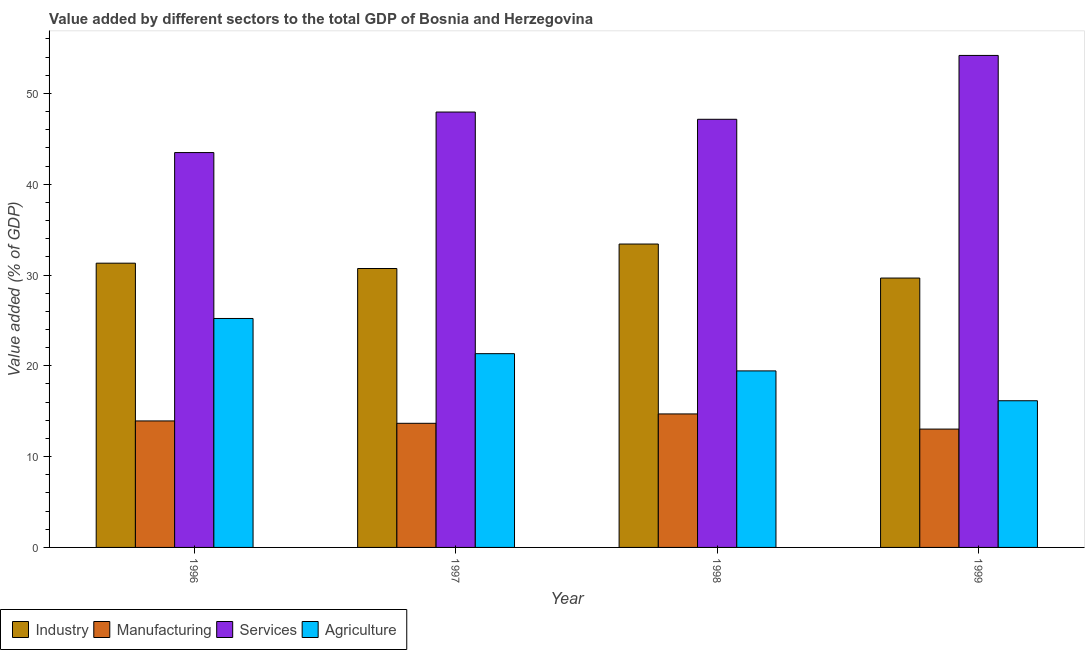How many different coloured bars are there?
Your response must be concise. 4. How many groups of bars are there?
Offer a very short reply. 4. Are the number of bars per tick equal to the number of legend labels?
Offer a terse response. Yes. How many bars are there on the 2nd tick from the left?
Your answer should be compact. 4. In how many cases, is the number of bars for a given year not equal to the number of legend labels?
Make the answer very short. 0. What is the value added by industrial sector in 1998?
Offer a very short reply. 33.41. Across all years, what is the maximum value added by services sector?
Offer a terse response. 54.18. Across all years, what is the minimum value added by manufacturing sector?
Offer a terse response. 13.03. In which year was the value added by services sector maximum?
Offer a terse response. 1999. What is the total value added by industrial sector in the graph?
Your response must be concise. 125.09. What is the difference between the value added by agricultural sector in 1997 and that in 1998?
Offer a terse response. 1.9. What is the difference between the value added by industrial sector in 1997 and the value added by services sector in 1998?
Your answer should be compact. -2.69. What is the average value added by industrial sector per year?
Keep it short and to the point. 31.27. What is the ratio of the value added by industrial sector in 1997 to that in 1999?
Your response must be concise. 1.04. Is the difference between the value added by manufacturing sector in 1997 and 1999 greater than the difference between the value added by services sector in 1997 and 1999?
Make the answer very short. No. What is the difference between the highest and the second highest value added by agricultural sector?
Offer a terse response. 3.88. What is the difference between the highest and the lowest value added by manufacturing sector?
Your response must be concise. 1.67. In how many years, is the value added by services sector greater than the average value added by services sector taken over all years?
Offer a very short reply. 1. Is the sum of the value added by industrial sector in 1996 and 1998 greater than the maximum value added by services sector across all years?
Your answer should be compact. Yes. What does the 2nd bar from the left in 1998 represents?
Ensure brevity in your answer.  Manufacturing. What does the 1st bar from the right in 1996 represents?
Your answer should be very brief. Agriculture. How many bars are there?
Your answer should be compact. 16. How many years are there in the graph?
Provide a succinct answer. 4. Are the values on the major ticks of Y-axis written in scientific E-notation?
Your response must be concise. No. Does the graph contain grids?
Give a very brief answer. No. What is the title of the graph?
Your response must be concise. Value added by different sectors to the total GDP of Bosnia and Herzegovina. What is the label or title of the X-axis?
Keep it short and to the point. Year. What is the label or title of the Y-axis?
Make the answer very short. Value added (% of GDP). What is the Value added (% of GDP) in Industry in 1996?
Offer a very short reply. 31.3. What is the Value added (% of GDP) in Manufacturing in 1996?
Your answer should be very brief. 13.93. What is the Value added (% of GDP) in Services in 1996?
Offer a very short reply. 43.48. What is the Value added (% of GDP) of Agriculture in 1996?
Your answer should be very brief. 25.21. What is the Value added (% of GDP) of Industry in 1997?
Your response must be concise. 30.72. What is the Value added (% of GDP) in Manufacturing in 1997?
Your response must be concise. 13.67. What is the Value added (% of GDP) in Services in 1997?
Keep it short and to the point. 47.95. What is the Value added (% of GDP) of Agriculture in 1997?
Your answer should be very brief. 21.34. What is the Value added (% of GDP) of Industry in 1998?
Provide a succinct answer. 33.41. What is the Value added (% of GDP) of Manufacturing in 1998?
Your answer should be very brief. 14.7. What is the Value added (% of GDP) of Services in 1998?
Ensure brevity in your answer.  47.15. What is the Value added (% of GDP) in Agriculture in 1998?
Give a very brief answer. 19.44. What is the Value added (% of GDP) of Industry in 1999?
Ensure brevity in your answer.  29.66. What is the Value added (% of GDP) of Manufacturing in 1999?
Offer a terse response. 13.03. What is the Value added (% of GDP) in Services in 1999?
Provide a short and direct response. 54.18. What is the Value added (% of GDP) of Agriculture in 1999?
Your response must be concise. 16.15. Across all years, what is the maximum Value added (% of GDP) in Industry?
Your response must be concise. 33.41. Across all years, what is the maximum Value added (% of GDP) in Manufacturing?
Your answer should be very brief. 14.7. Across all years, what is the maximum Value added (% of GDP) of Services?
Give a very brief answer. 54.18. Across all years, what is the maximum Value added (% of GDP) in Agriculture?
Offer a terse response. 25.21. Across all years, what is the minimum Value added (% of GDP) of Industry?
Your response must be concise. 29.66. Across all years, what is the minimum Value added (% of GDP) of Manufacturing?
Provide a short and direct response. 13.03. Across all years, what is the minimum Value added (% of GDP) of Services?
Your response must be concise. 43.48. Across all years, what is the minimum Value added (% of GDP) of Agriculture?
Your response must be concise. 16.15. What is the total Value added (% of GDP) in Industry in the graph?
Keep it short and to the point. 125.09. What is the total Value added (% of GDP) in Manufacturing in the graph?
Your answer should be compact. 55.33. What is the total Value added (% of GDP) in Services in the graph?
Provide a succinct answer. 192.76. What is the total Value added (% of GDP) of Agriculture in the graph?
Give a very brief answer. 82.14. What is the difference between the Value added (% of GDP) in Industry in 1996 and that in 1997?
Provide a short and direct response. 0.59. What is the difference between the Value added (% of GDP) of Manufacturing in 1996 and that in 1997?
Give a very brief answer. 0.26. What is the difference between the Value added (% of GDP) in Services in 1996 and that in 1997?
Give a very brief answer. -4.46. What is the difference between the Value added (% of GDP) of Agriculture in 1996 and that in 1997?
Provide a short and direct response. 3.88. What is the difference between the Value added (% of GDP) in Industry in 1996 and that in 1998?
Make the answer very short. -2.11. What is the difference between the Value added (% of GDP) in Manufacturing in 1996 and that in 1998?
Make the answer very short. -0.77. What is the difference between the Value added (% of GDP) in Services in 1996 and that in 1998?
Your answer should be compact. -3.67. What is the difference between the Value added (% of GDP) in Agriculture in 1996 and that in 1998?
Offer a terse response. 5.77. What is the difference between the Value added (% of GDP) in Industry in 1996 and that in 1999?
Provide a succinct answer. 1.64. What is the difference between the Value added (% of GDP) of Manufacturing in 1996 and that in 1999?
Keep it short and to the point. 0.9. What is the difference between the Value added (% of GDP) in Services in 1996 and that in 1999?
Offer a very short reply. -10.7. What is the difference between the Value added (% of GDP) of Agriculture in 1996 and that in 1999?
Make the answer very short. 9.06. What is the difference between the Value added (% of GDP) in Industry in 1997 and that in 1998?
Provide a succinct answer. -2.69. What is the difference between the Value added (% of GDP) in Manufacturing in 1997 and that in 1998?
Give a very brief answer. -1.03. What is the difference between the Value added (% of GDP) in Services in 1997 and that in 1998?
Give a very brief answer. 0.8. What is the difference between the Value added (% of GDP) of Agriculture in 1997 and that in 1998?
Ensure brevity in your answer.  1.9. What is the difference between the Value added (% of GDP) of Industry in 1997 and that in 1999?
Offer a very short reply. 1.05. What is the difference between the Value added (% of GDP) of Manufacturing in 1997 and that in 1999?
Ensure brevity in your answer.  0.64. What is the difference between the Value added (% of GDP) in Services in 1997 and that in 1999?
Your answer should be compact. -6.24. What is the difference between the Value added (% of GDP) of Agriculture in 1997 and that in 1999?
Provide a short and direct response. 5.18. What is the difference between the Value added (% of GDP) of Industry in 1998 and that in 1999?
Your answer should be compact. 3.75. What is the difference between the Value added (% of GDP) of Manufacturing in 1998 and that in 1999?
Ensure brevity in your answer.  1.67. What is the difference between the Value added (% of GDP) in Services in 1998 and that in 1999?
Offer a very short reply. -7.03. What is the difference between the Value added (% of GDP) in Agriculture in 1998 and that in 1999?
Your answer should be very brief. 3.29. What is the difference between the Value added (% of GDP) of Industry in 1996 and the Value added (% of GDP) of Manufacturing in 1997?
Offer a terse response. 17.63. What is the difference between the Value added (% of GDP) in Industry in 1996 and the Value added (% of GDP) in Services in 1997?
Offer a very short reply. -16.64. What is the difference between the Value added (% of GDP) in Industry in 1996 and the Value added (% of GDP) in Agriculture in 1997?
Give a very brief answer. 9.97. What is the difference between the Value added (% of GDP) in Manufacturing in 1996 and the Value added (% of GDP) in Services in 1997?
Offer a terse response. -34.02. What is the difference between the Value added (% of GDP) in Manufacturing in 1996 and the Value added (% of GDP) in Agriculture in 1997?
Your response must be concise. -7.41. What is the difference between the Value added (% of GDP) in Services in 1996 and the Value added (% of GDP) in Agriculture in 1997?
Ensure brevity in your answer.  22.15. What is the difference between the Value added (% of GDP) in Industry in 1996 and the Value added (% of GDP) in Manufacturing in 1998?
Your answer should be very brief. 16.6. What is the difference between the Value added (% of GDP) of Industry in 1996 and the Value added (% of GDP) of Services in 1998?
Your answer should be compact. -15.85. What is the difference between the Value added (% of GDP) of Industry in 1996 and the Value added (% of GDP) of Agriculture in 1998?
Offer a terse response. 11.86. What is the difference between the Value added (% of GDP) of Manufacturing in 1996 and the Value added (% of GDP) of Services in 1998?
Give a very brief answer. -33.22. What is the difference between the Value added (% of GDP) of Manufacturing in 1996 and the Value added (% of GDP) of Agriculture in 1998?
Provide a succinct answer. -5.51. What is the difference between the Value added (% of GDP) in Services in 1996 and the Value added (% of GDP) in Agriculture in 1998?
Provide a short and direct response. 24.04. What is the difference between the Value added (% of GDP) of Industry in 1996 and the Value added (% of GDP) of Manufacturing in 1999?
Keep it short and to the point. 18.27. What is the difference between the Value added (% of GDP) of Industry in 1996 and the Value added (% of GDP) of Services in 1999?
Ensure brevity in your answer.  -22.88. What is the difference between the Value added (% of GDP) of Industry in 1996 and the Value added (% of GDP) of Agriculture in 1999?
Offer a very short reply. 15.15. What is the difference between the Value added (% of GDP) in Manufacturing in 1996 and the Value added (% of GDP) in Services in 1999?
Provide a short and direct response. -40.25. What is the difference between the Value added (% of GDP) of Manufacturing in 1996 and the Value added (% of GDP) of Agriculture in 1999?
Offer a very short reply. -2.22. What is the difference between the Value added (% of GDP) in Services in 1996 and the Value added (% of GDP) in Agriculture in 1999?
Offer a very short reply. 27.33. What is the difference between the Value added (% of GDP) of Industry in 1997 and the Value added (% of GDP) of Manufacturing in 1998?
Offer a very short reply. 16.02. What is the difference between the Value added (% of GDP) in Industry in 1997 and the Value added (% of GDP) in Services in 1998?
Offer a terse response. -16.43. What is the difference between the Value added (% of GDP) in Industry in 1997 and the Value added (% of GDP) in Agriculture in 1998?
Your response must be concise. 11.28. What is the difference between the Value added (% of GDP) of Manufacturing in 1997 and the Value added (% of GDP) of Services in 1998?
Provide a succinct answer. -33.48. What is the difference between the Value added (% of GDP) in Manufacturing in 1997 and the Value added (% of GDP) in Agriculture in 1998?
Your response must be concise. -5.77. What is the difference between the Value added (% of GDP) of Services in 1997 and the Value added (% of GDP) of Agriculture in 1998?
Your response must be concise. 28.51. What is the difference between the Value added (% of GDP) in Industry in 1997 and the Value added (% of GDP) in Manufacturing in 1999?
Your response must be concise. 17.68. What is the difference between the Value added (% of GDP) of Industry in 1997 and the Value added (% of GDP) of Services in 1999?
Your answer should be compact. -23.47. What is the difference between the Value added (% of GDP) in Industry in 1997 and the Value added (% of GDP) in Agriculture in 1999?
Offer a very short reply. 14.56. What is the difference between the Value added (% of GDP) of Manufacturing in 1997 and the Value added (% of GDP) of Services in 1999?
Your response must be concise. -40.51. What is the difference between the Value added (% of GDP) in Manufacturing in 1997 and the Value added (% of GDP) in Agriculture in 1999?
Your answer should be very brief. -2.48. What is the difference between the Value added (% of GDP) of Services in 1997 and the Value added (% of GDP) of Agriculture in 1999?
Keep it short and to the point. 31.79. What is the difference between the Value added (% of GDP) of Industry in 1998 and the Value added (% of GDP) of Manufacturing in 1999?
Provide a succinct answer. 20.38. What is the difference between the Value added (% of GDP) in Industry in 1998 and the Value added (% of GDP) in Services in 1999?
Give a very brief answer. -20.77. What is the difference between the Value added (% of GDP) in Industry in 1998 and the Value added (% of GDP) in Agriculture in 1999?
Ensure brevity in your answer.  17.26. What is the difference between the Value added (% of GDP) in Manufacturing in 1998 and the Value added (% of GDP) in Services in 1999?
Keep it short and to the point. -39.48. What is the difference between the Value added (% of GDP) of Manufacturing in 1998 and the Value added (% of GDP) of Agriculture in 1999?
Provide a short and direct response. -1.45. What is the difference between the Value added (% of GDP) of Services in 1998 and the Value added (% of GDP) of Agriculture in 1999?
Offer a terse response. 31. What is the average Value added (% of GDP) of Industry per year?
Offer a very short reply. 31.27. What is the average Value added (% of GDP) in Manufacturing per year?
Your response must be concise. 13.83. What is the average Value added (% of GDP) in Services per year?
Make the answer very short. 48.19. What is the average Value added (% of GDP) in Agriculture per year?
Your response must be concise. 20.54. In the year 1996, what is the difference between the Value added (% of GDP) in Industry and Value added (% of GDP) in Manufacturing?
Make the answer very short. 17.37. In the year 1996, what is the difference between the Value added (% of GDP) in Industry and Value added (% of GDP) in Services?
Your answer should be very brief. -12.18. In the year 1996, what is the difference between the Value added (% of GDP) in Industry and Value added (% of GDP) in Agriculture?
Make the answer very short. 6.09. In the year 1996, what is the difference between the Value added (% of GDP) of Manufacturing and Value added (% of GDP) of Services?
Offer a terse response. -29.55. In the year 1996, what is the difference between the Value added (% of GDP) in Manufacturing and Value added (% of GDP) in Agriculture?
Ensure brevity in your answer.  -11.28. In the year 1996, what is the difference between the Value added (% of GDP) of Services and Value added (% of GDP) of Agriculture?
Provide a succinct answer. 18.27. In the year 1997, what is the difference between the Value added (% of GDP) in Industry and Value added (% of GDP) in Manufacturing?
Keep it short and to the point. 17.05. In the year 1997, what is the difference between the Value added (% of GDP) of Industry and Value added (% of GDP) of Services?
Your answer should be very brief. -17.23. In the year 1997, what is the difference between the Value added (% of GDP) of Industry and Value added (% of GDP) of Agriculture?
Give a very brief answer. 9.38. In the year 1997, what is the difference between the Value added (% of GDP) of Manufacturing and Value added (% of GDP) of Services?
Give a very brief answer. -34.28. In the year 1997, what is the difference between the Value added (% of GDP) of Manufacturing and Value added (% of GDP) of Agriculture?
Provide a succinct answer. -7.67. In the year 1997, what is the difference between the Value added (% of GDP) of Services and Value added (% of GDP) of Agriculture?
Provide a succinct answer. 26.61. In the year 1998, what is the difference between the Value added (% of GDP) in Industry and Value added (% of GDP) in Manufacturing?
Offer a terse response. 18.71. In the year 1998, what is the difference between the Value added (% of GDP) of Industry and Value added (% of GDP) of Services?
Ensure brevity in your answer.  -13.74. In the year 1998, what is the difference between the Value added (% of GDP) in Industry and Value added (% of GDP) in Agriculture?
Offer a terse response. 13.97. In the year 1998, what is the difference between the Value added (% of GDP) in Manufacturing and Value added (% of GDP) in Services?
Give a very brief answer. -32.45. In the year 1998, what is the difference between the Value added (% of GDP) of Manufacturing and Value added (% of GDP) of Agriculture?
Your answer should be very brief. -4.74. In the year 1998, what is the difference between the Value added (% of GDP) of Services and Value added (% of GDP) of Agriculture?
Keep it short and to the point. 27.71. In the year 1999, what is the difference between the Value added (% of GDP) in Industry and Value added (% of GDP) in Manufacturing?
Give a very brief answer. 16.63. In the year 1999, what is the difference between the Value added (% of GDP) in Industry and Value added (% of GDP) in Services?
Your answer should be very brief. -24.52. In the year 1999, what is the difference between the Value added (% of GDP) of Industry and Value added (% of GDP) of Agriculture?
Keep it short and to the point. 13.51. In the year 1999, what is the difference between the Value added (% of GDP) of Manufacturing and Value added (% of GDP) of Services?
Your response must be concise. -41.15. In the year 1999, what is the difference between the Value added (% of GDP) in Manufacturing and Value added (% of GDP) in Agriculture?
Your answer should be very brief. -3.12. In the year 1999, what is the difference between the Value added (% of GDP) in Services and Value added (% of GDP) in Agriculture?
Your response must be concise. 38.03. What is the ratio of the Value added (% of GDP) of Industry in 1996 to that in 1997?
Your response must be concise. 1.02. What is the ratio of the Value added (% of GDP) in Manufacturing in 1996 to that in 1997?
Offer a terse response. 1.02. What is the ratio of the Value added (% of GDP) of Services in 1996 to that in 1997?
Your response must be concise. 0.91. What is the ratio of the Value added (% of GDP) in Agriculture in 1996 to that in 1997?
Ensure brevity in your answer.  1.18. What is the ratio of the Value added (% of GDP) in Industry in 1996 to that in 1998?
Offer a terse response. 0.94. What is the ratio of the Value added (% of GDP) in Manufacturing in 1996 to that in 1998?
Make the answer very short. 0.95. What is the ratio of the Value added (% of GDP) of Services in 1996 to that in 1998?
Offer a very short reply. 0.92. What is the ratio of the Value added (% of GDP) in Agriculture in 1996 to that in 1998?
Ensure brevity in your answer.  1.3. What is the ratio of the Value added (% of GDP) in Industry in 1996 to that in 1999?
Your response must be concise. 1.06. What is the ratio of the Value added (% of GDP) in Manufacturing in 1996 to that in 1999?
Offer a very short reply. 1.07. What is the ratio of the Value added (% of GDP) of Services in 1996 to that in 1999?
Offer a very short reply. 0.8. What is the ratio of the Value added (% of GDP) in Agriculture in 1996 to that in 1999?
Give a very brief answer. 1.56. What is the ratio of the Value added (% of GDP) in Industry in 1997 to that in 1998?
Provide a short and direct response. 0.92. What is the ratio of the Value added (% of GDP) of Manufacturing in 1997 to that in 1998?
Offer a very short reply. 0.93. What is the ratio of the Value added (% of GDP) in Services in 1997 to that in 1998?
Your response must be concise. 1.02. What is the ratio of the Value added (% of GDP) of Agriculture in 1997 to that in 1998?
Your answer should be very brief. 1.1. What is the ratio of the Value added (% of GDP) in Industry in 1997 to that in 1999?
Your response must be concise. 1.04. What is the ratio of the Value added (% of GDP) of Manufacturing in 1997 to that in 1999?
Provide a succinct answer. 1.05. What is the ratio of the Value added (% of GDP) in Services in 1997 to that in 1999?
Your response must be concise. 0.88. What is the ratio of the Value added (% of GDP) in Agriculture in 1997 to that in 1999?
Offer a terse response. 1.32. What is the ratio of the Value added (% of GDP) of Industry in 1998 to that in 1999?
Ensure brevity in your answer.  1.13. What is the ratio of the Value added (% of GDP) of Manufacturing in 1998 to that in 1999?
Provide a succinct answer. 1.13. What is the ratio of the Value added (% of GDP) in Services in 1998 to that in 1999?
Ensure brevity in your answer.  0.87. What is the ratio of the Value added (% of GDP) of Agriculture in 1998 to that in 1999?
Make the answer very short. 1.2. What is the difference between the highest and the second highest Value added (% of GDP) in Industry?
Provide a succinct answer. 2.11. What is the difference between the highest and the second highest Value added (% of GDP) of Manufacturing?
Ensure brevity in your answer.  0.77. What is the difference between the highest and the second highest Value added (% of GDP) of Services?
Your response must be concise. 6.24. What is the difference between the highest and the second highest Value added (% of GDP) in Agriculture?
Your response must be concise. 3.88. What is the difference between the highest and the lowest Value added (% of GDP) in Industry?
Your answer should be very brief. 3.75. What is the difference between the highest and the lowest Value added (% of GDP) of Manufacturing?
Keep it short and to the point. 1.67. What is the difference between the highest and the lowest Value added (% of GDP) of Services?
Your response must be concise. 10.7. What is the difference between the highest and the lowest Value added (% of GDP) in Agriculture?
Offer a terse response. 9.06. 